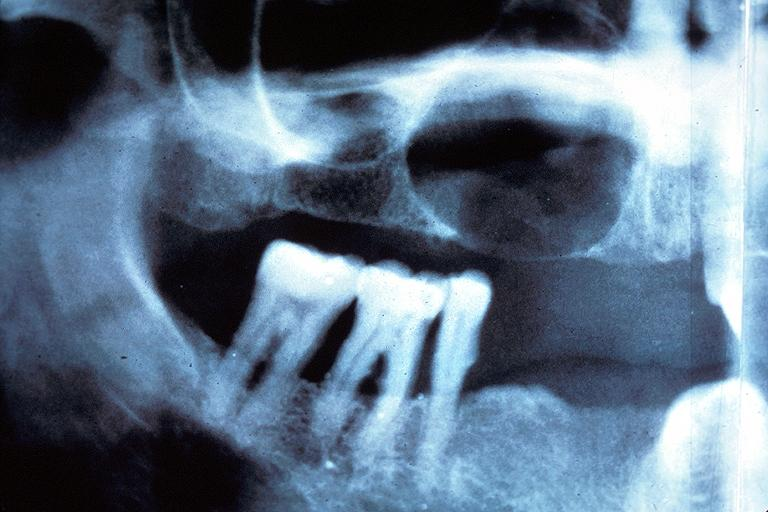what does this image show?
Answer the question using a single word or phrase. Residual cyst 